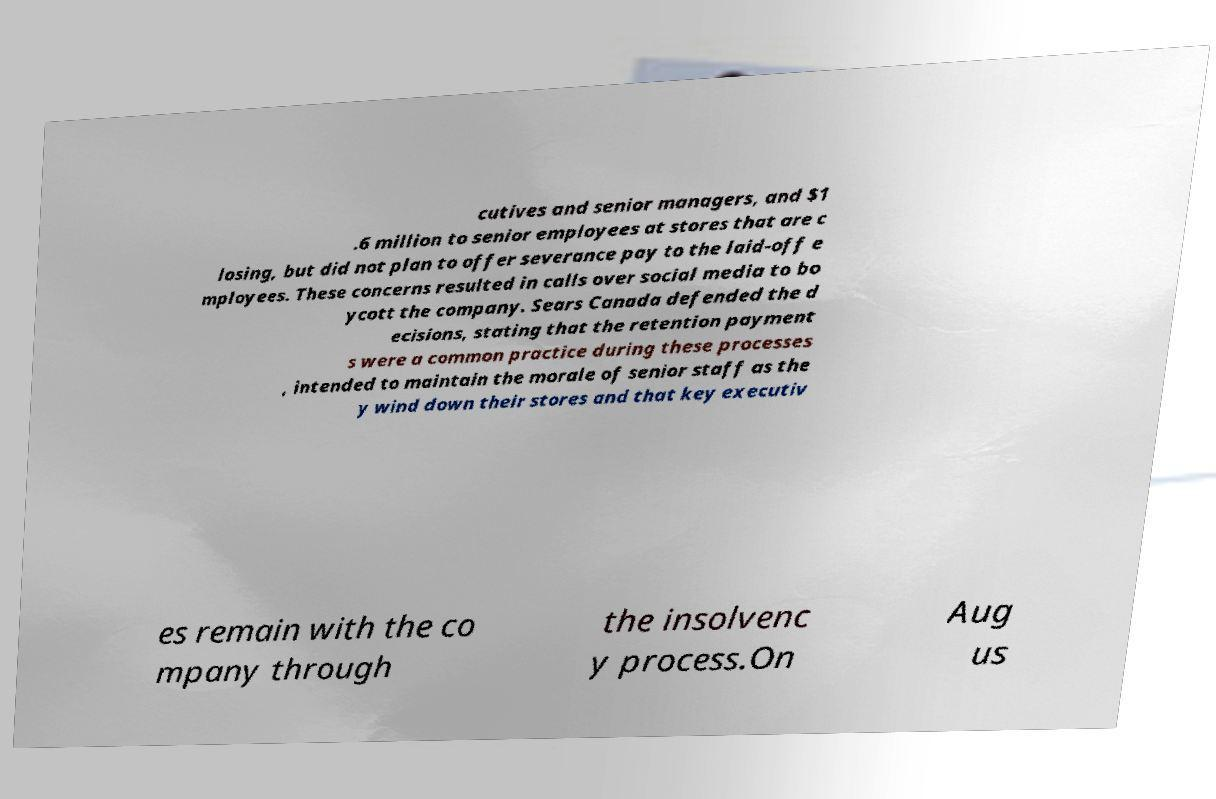I need the written content from this picture converted into text. Can you do that? cutives and senior managers, and $1 .6 million to senior employees at stores that are c losing, but did not plan to offer severance pay to the laid-off e mployees. These concerns resulted in calls over social media to bo ycott the company. Sears Canada defended the d ecisions, stating that the retention payment s were a common practice during these processes , intended to maintain the morale of senior staff as the y wind down their stores and that key executiv es remain with the co mpany through the insolvenc y process.On Aug us 